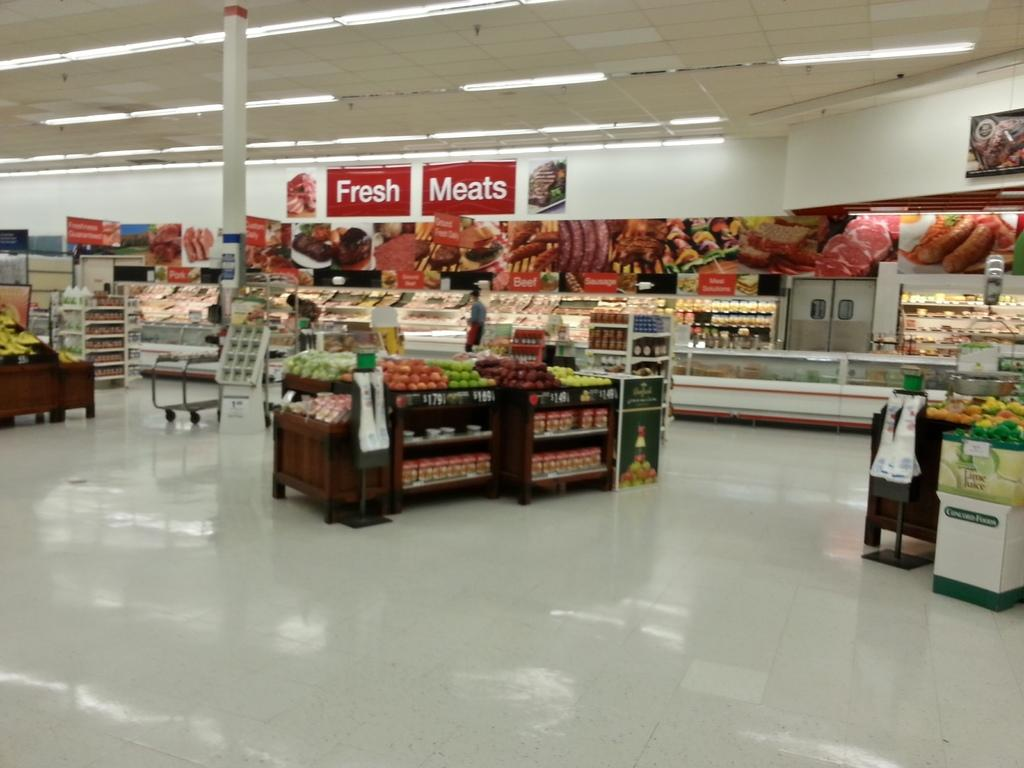<image>
Relay a brief, clear account of the picture shown. Section of a grocery store where the Fresh Meats are placed. 